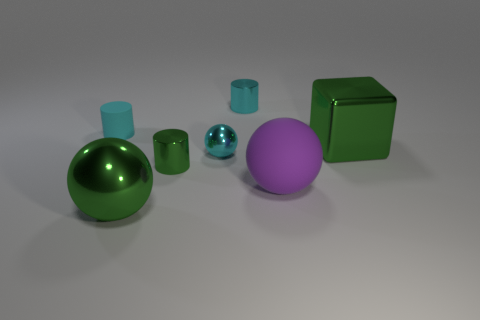There is a tiny metallic cylinder behind the matte cylinder; is it the same color as the rubber object that is to the left of the large purple sphere?
Ensure brevity in your answer.  Yes. There is a cyan cylinder behind the cyan cylinder that is in front of the cylinder that is behind the cyan rubber object; what size is it?
Your response must be concise. Small. How many cyan objects are tiny matte things or blocks?
Your answer should be very brief. 1. Are there more big purple matte objects than red shiny things?
Make the answer very short. Yes. How many objects are tiny things in front of the shiny cube or green things that are behind the matte sphere?
Your answer should be compact. 3. There is a shiny ball that is the same size as the cyan matte cylinder; what color is it?
Give a very brief answer. Cyan. Is the material of the big purple thing the same as the block?
Your answer should be compact. No. There is a tiny cyan cylinder on the right side of the tiny rubber object behind the large rubber thing; what is it made of?
Offer a terse response. Metal. Are there more large matte things that are behind the tiny cyan ball than tiny gray metallic things?
Ensure brevity in your answer.  No. How many other things are the same size as the green cylinder?
Give a very brief answer. 3. 